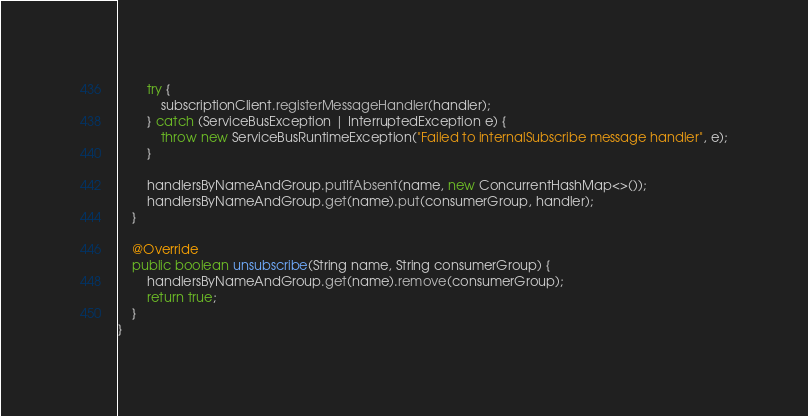Convert code to text. <code><loc_0><loc_0><loc_500><loc_500><_Java_>        try {
            subscriptionClient.registerMessageHandler(handler);
        } catch (ServiceBusException | InterruptedException e) {
            throw new ServiceBusRuntimeException("Failed to internalSubscribe message handler", e);
        }

        handlersByNameAndGroup.putIfAbsent(name, new ConcurrentHashMap<>());
        handlersByNameAndGroup.get(name).put(consumerGroup, handler);
    }

    @Override
    public boolean unsubscribe(String name, String consumerGroup) {
        handlersByNameAndGroup.get(name).remove(consumerGroup);
        return true;
    }
}

</code> 